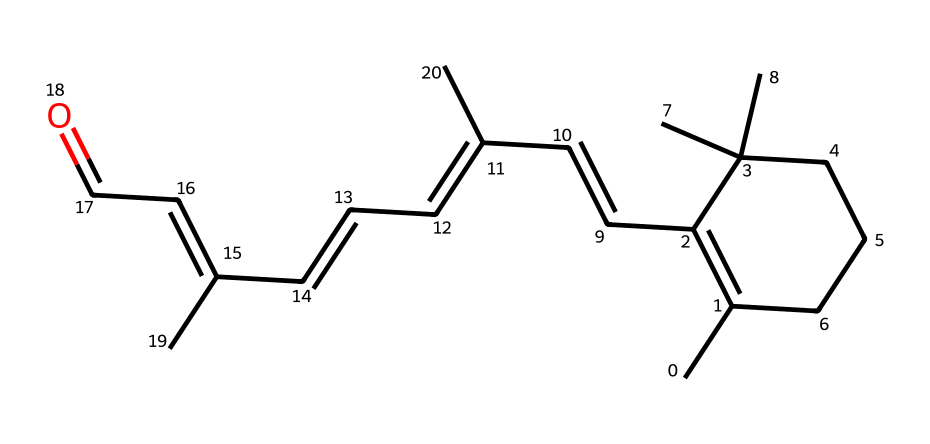How many carbon atoms are present in retinol? By analyzing the SMILES representation, we can count the carbon atoms. Each "C" in the SMILES indicates a carbon atom. Counting all the carbons shows that there are 20 carbon atoms.
Answer: 20 What functional group is present in retinol? In the provided structure, we can identify a carbonyl group (=O) attached to a carbon chain. This indicates that retinol contains a ketone functional group.
Answer: ketone How many double bonds are present in retinol? By examining the SMILES, we can identify the presence of double bonds denoted by "=" symbols. Counting these shows that there are 5 double bonds in the structure.
Answer: 5 Is retinol a saturated or unsaturated compound? Since retinol contains several double bonds, it is classified as an unsaturated compound. The presence of these double bonds indicates that not all carbon atoms are fully saturated with hydrogen.
Answer: unsaturated Which part of the retinol structure determines its characteristic color? The presence of conjugated double bonds throughout the structure allows for the absorption of light in the visible spectrum, which contributes to the characteristic color of retinol.
Answer: conjugated double bonds 